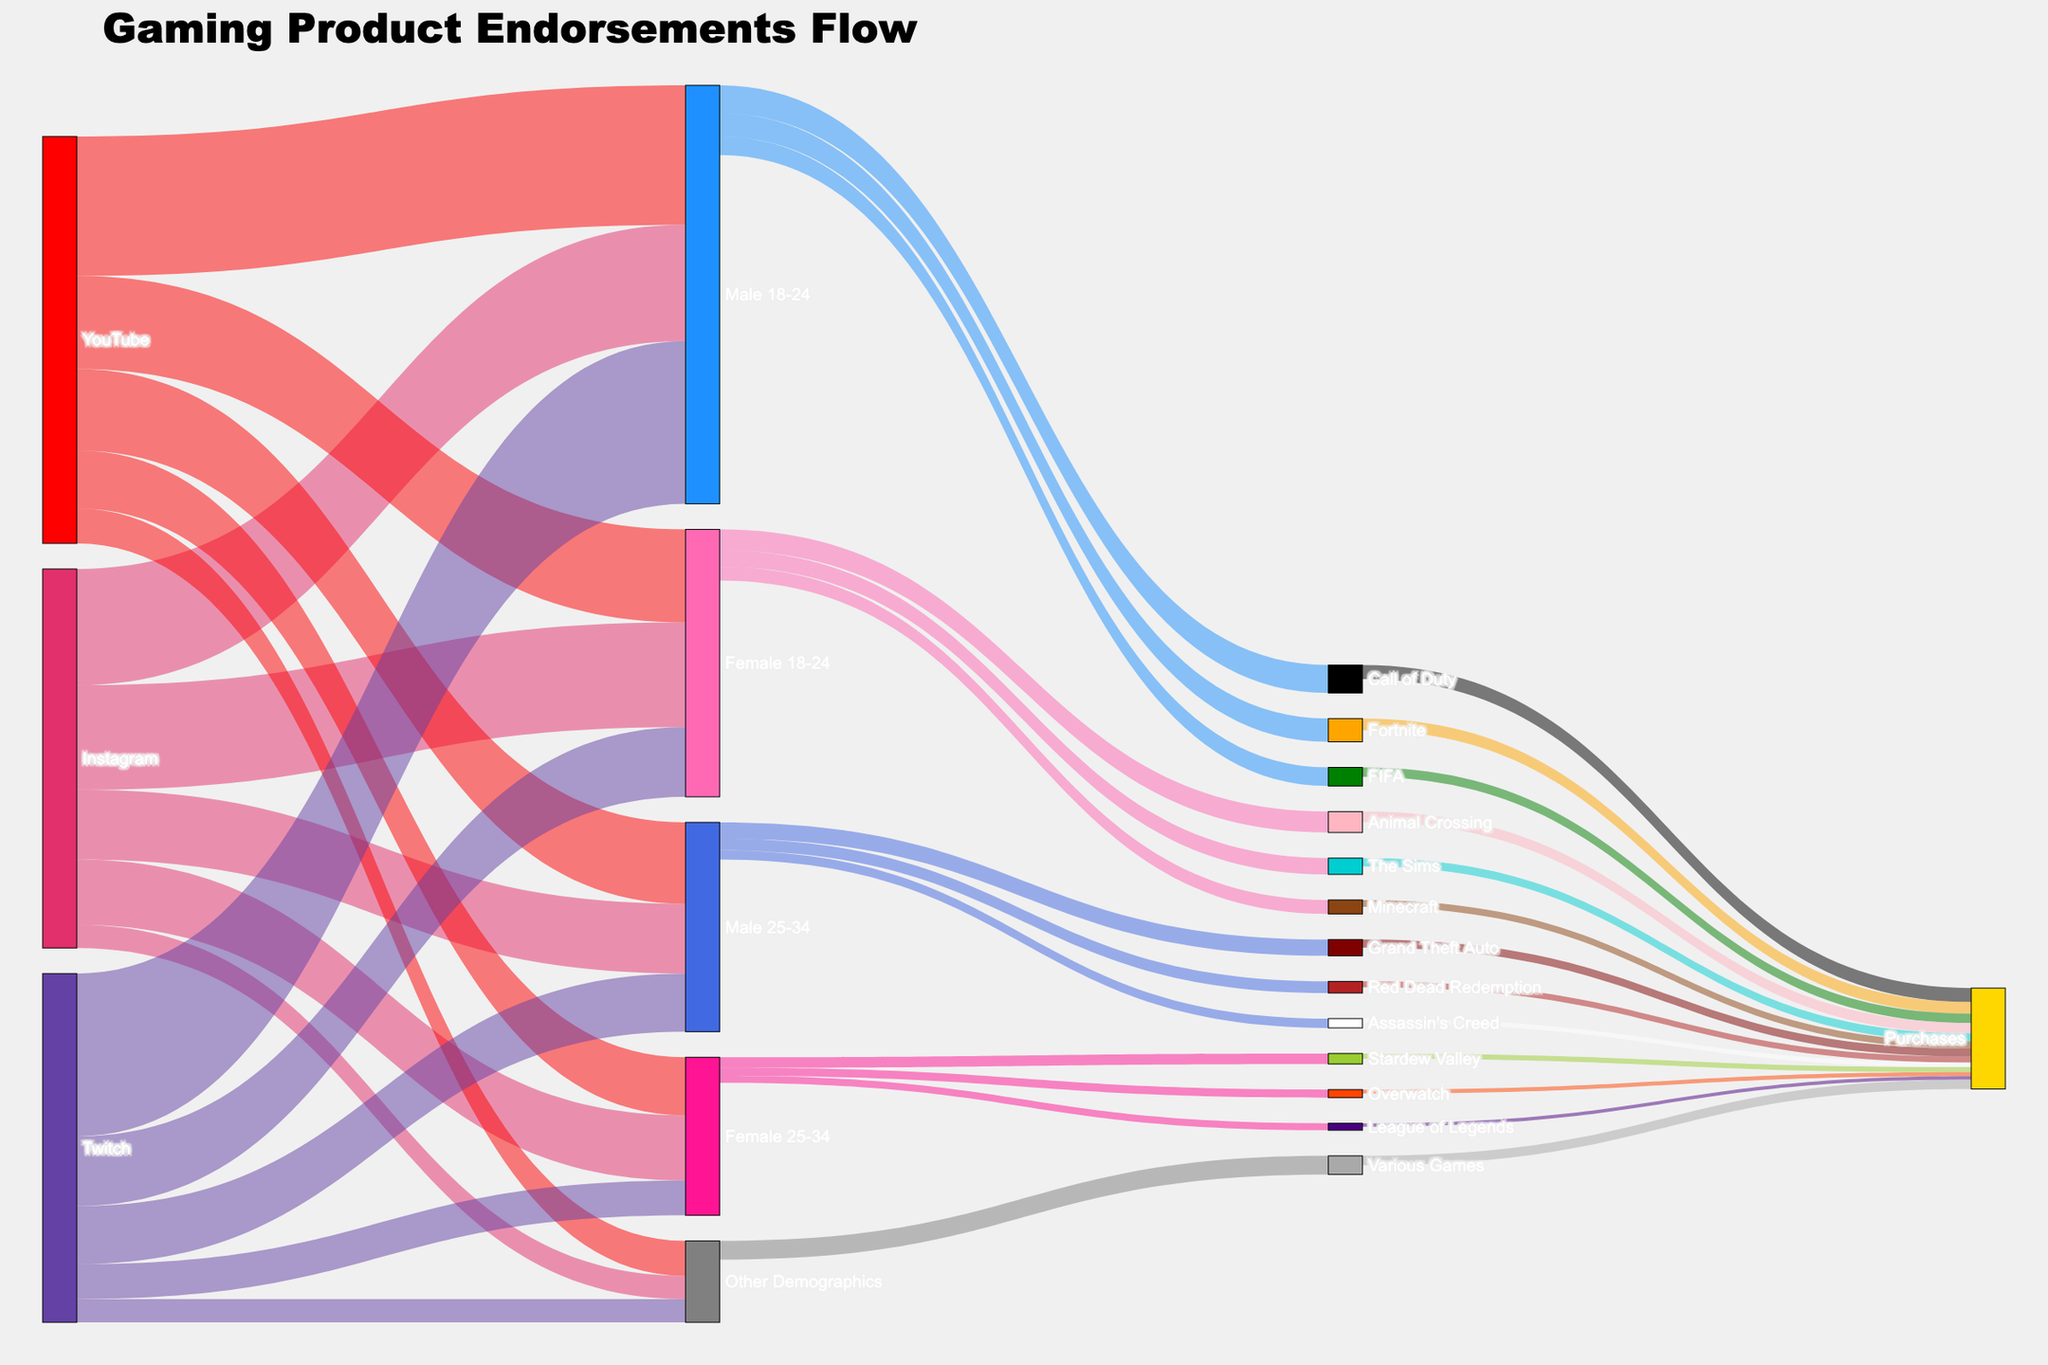What's the primary age group for gaming endorsements on Instagram? Look for the biggest value under 'Instagram' targeting different age groups. Compare these values visually.
Answer: Male 18-24 What's the combined conversion rate for the Male 18-24 demographic endorsing Call of Duty and Fortnite? Find the values for Male 18-24 converting to Call of Duty and Fortnite and sum them up: 120,000 (Call of Duty) + 100,000 (Fortnite).
Answer: 220,000 Which social media platform has the most endorsements directed to Female 18-24? Compare the values directed to Female 18-24 from Instagram, YouTube, and Twitch. The highest value visually belongs to YouTube at 400,000.
Answer: YouTube How many total purchases were generated by endorsements for Male 25-34? Sum values for Male 25-34 converting to games then total purchases: Grand Theft Auto (35,000), Red Dead Redemption (25,000), and Assassin's Creed (20,000).
Answer: 80,000 What is the largest single conversion to purchases from any game endorsement? Identify the biggest number among game-to-purchases conversions. Check the values visually, which include: Call of Duty (60,000), Fortnite (50,000), etc.
Answer: Call of Duty - 60,000 Which gender demographic has the highest conversion for gaming endorsements? Look at the sum of values directed to the Male and Female demographics, then compare the totals. Male seems higher visually when summing the relevant values compared to Female.
Answer: Male From which platform did the Female 25-34 demographic receive the least endorsements? Compare the values for Female 25-34 between Instagram (280,000), YouTube (250,000), and Twitch (150,000). The least endorsements come from Twitch.
Answer: Twitch How do the conversion rates for Male 18-24 to FIFA and Animal Crossing compare? Retrieve the values, 80,000 for FIFA and 45,000 for Animal Crossing. FIFA is higher than Animal Crossing.
Answer: FIFA is higher What is the total amount of purchases across all demographics and games? Sum up all the 'Purchases' values: 60,000 + 50,000 + 40,000 + 45,000 + 35,000 + 30,000 + 35,000 + 25,000 + 20,000 + 22,000 + 17,000 + 15,000 + 40,000.
Answer: 434,000 